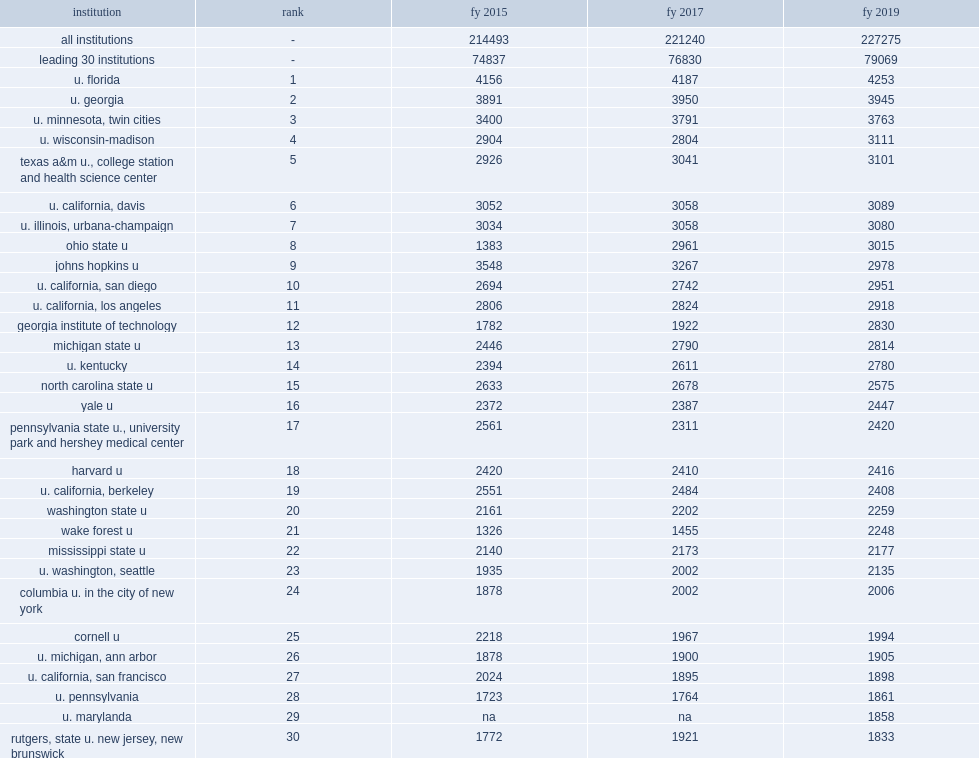Write the full table. {'header': ['institution', 'rank', 'fy 2015', 'fy 2017', 'fy 2019'], 'rows': [['all institutions', '-', '214493', '221240', '227275'], ['leading 30 institutions', '-', '74837', '76830', '79069'], ['u. florida', '1', '4156', '4187', '4253'], ['u. georgia', '2', '3891', '3950', '3945'], ['u. minnesota, twin cities', '3', '3400', '3791', '3763'], ['u. wisconsin-madison', '4', '2904', '2804', '3111'], ['texas a&m u., college station and health science center', '5', '2926', '3041', '3101'], ['u. california, davis', '6', '3052', '3058', '3089'], ['u. illinois, urbana-champaign', '7', '3034', '3058', '3080'], ['ohio state u', '8', '1383', '2961', '3015'], ['johns hopkins u', '9', '3548', '3267', '2978'], ['u. california, san diego', '10', '2694', '2742', '2951'], ['u. california, los angeles', '11', '2806', '2824', '2918'], ['georgia institute of technology', '12', '1782', '1922', '2830'], ['michigan state u', '13', '2446', '2790', '2814'], ['u. kentucky', '14', '2394', '2611', '2780'], ['north carolina state u', '15', '2633', '2678', '2575'], ['yale u', '16', '2372', '2387', '2447'], ['pennsylvania state u., university park and hershey medical center', '17', '2561', '2311', '2420'], ['harvard u', '18', '2420', '2410', '2416'], ['u. california, berkeley', '19', '2551', '2484', '2408'], ['washington state u', '20', '2161', '2202', '2259'], ['wake forest u', '21', '1326', '1455', '2248'], ['mississippi state u', '22', '2140', '2173', '2177'], ['u. washington, seattle', '23', '1935', '2002', '2135'], ['columbia u. in the city of new york', '24', '1878', '2002', '2006'], ['cornell u', '25', '2218', '1967', '1994'], ['u. michigan, ann arbor', '26', '1878', '1900', '1905'], ['u. california, san francisco', '27', '2024', '1895', '1898'], ['u. pennsylvania', '28', '1723', '1764', '1861'], ['u. marylanda', '29', 'na', 'na', '1858'], ['rutgers, state u. new jersey, new brunswick', '30', '1772', '1921', '1833']]} Of the 590 institutions surveyed, how many percentage points did the top 30 institutions ranked by total s&e research nasf account for of all research space in fy 2019? 0.3479. 